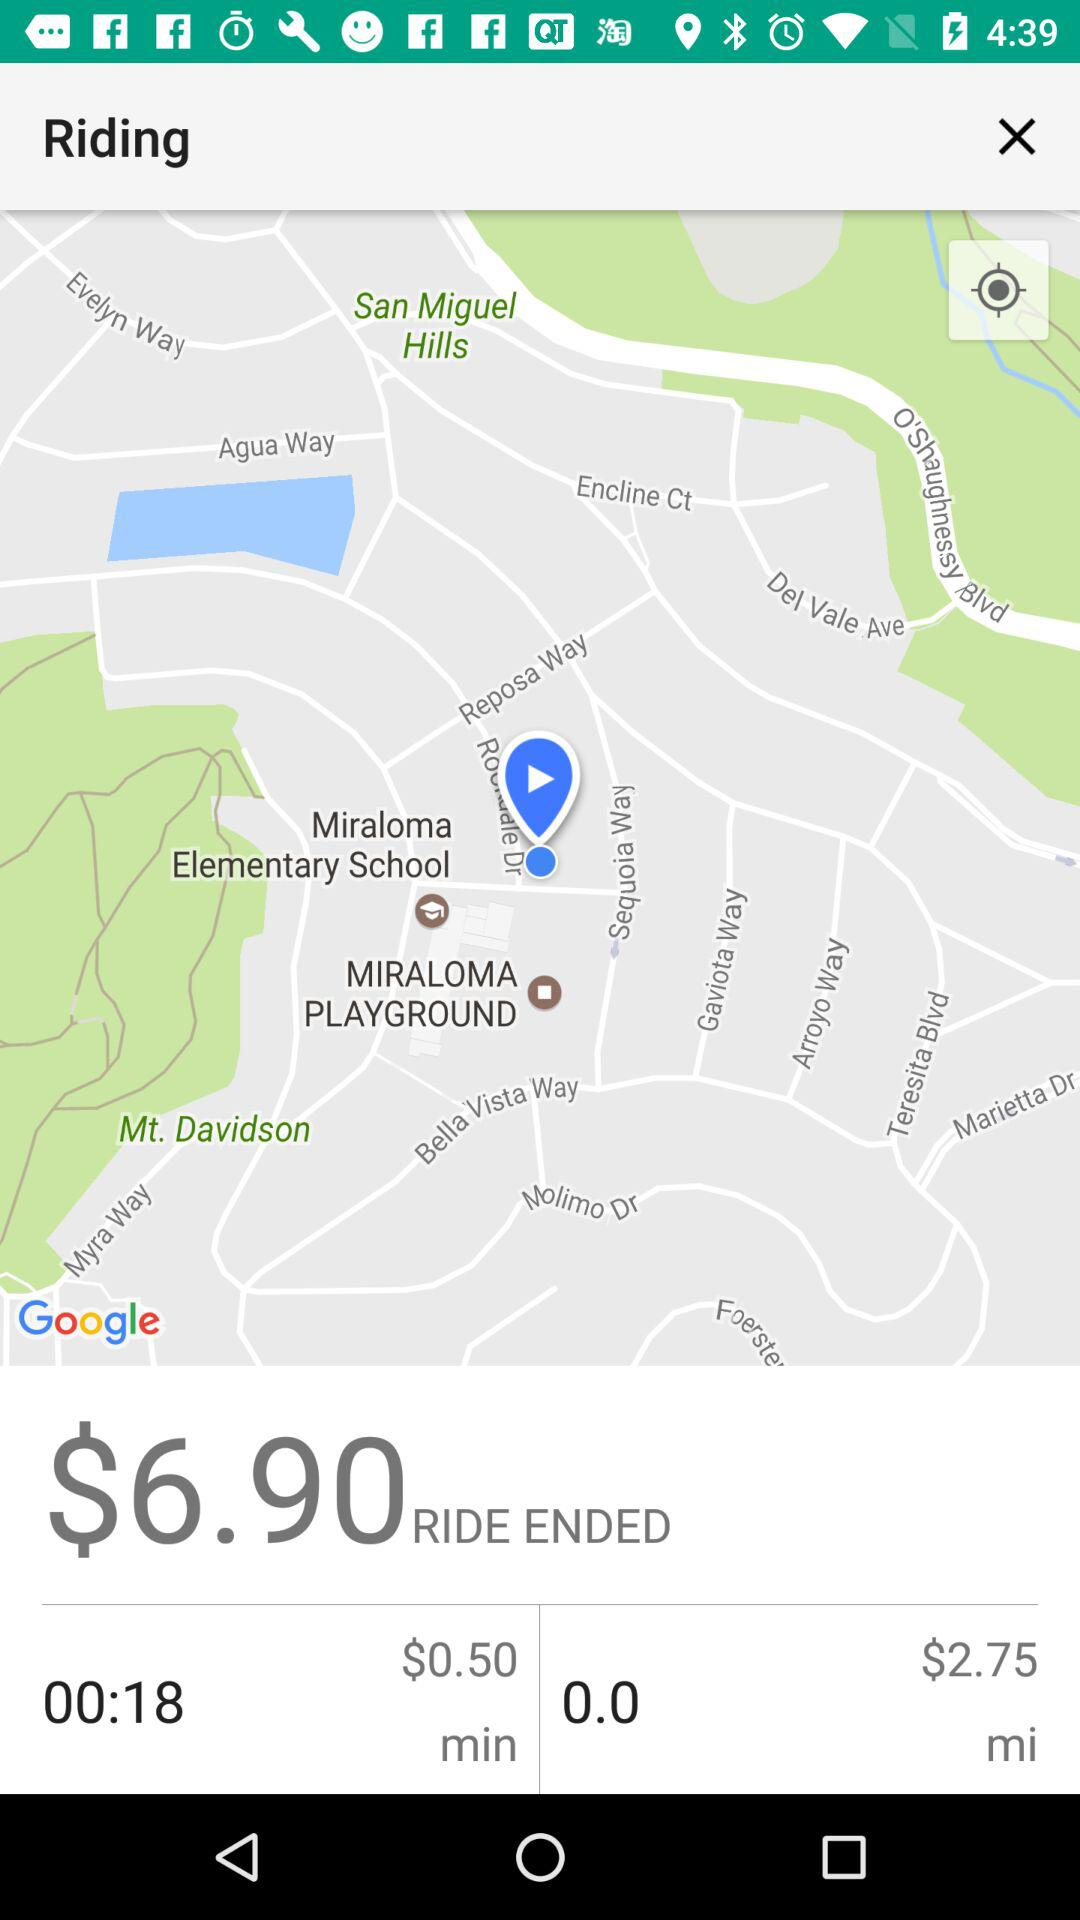What is the fare for the ride? The fare for the ride is $6.90. 